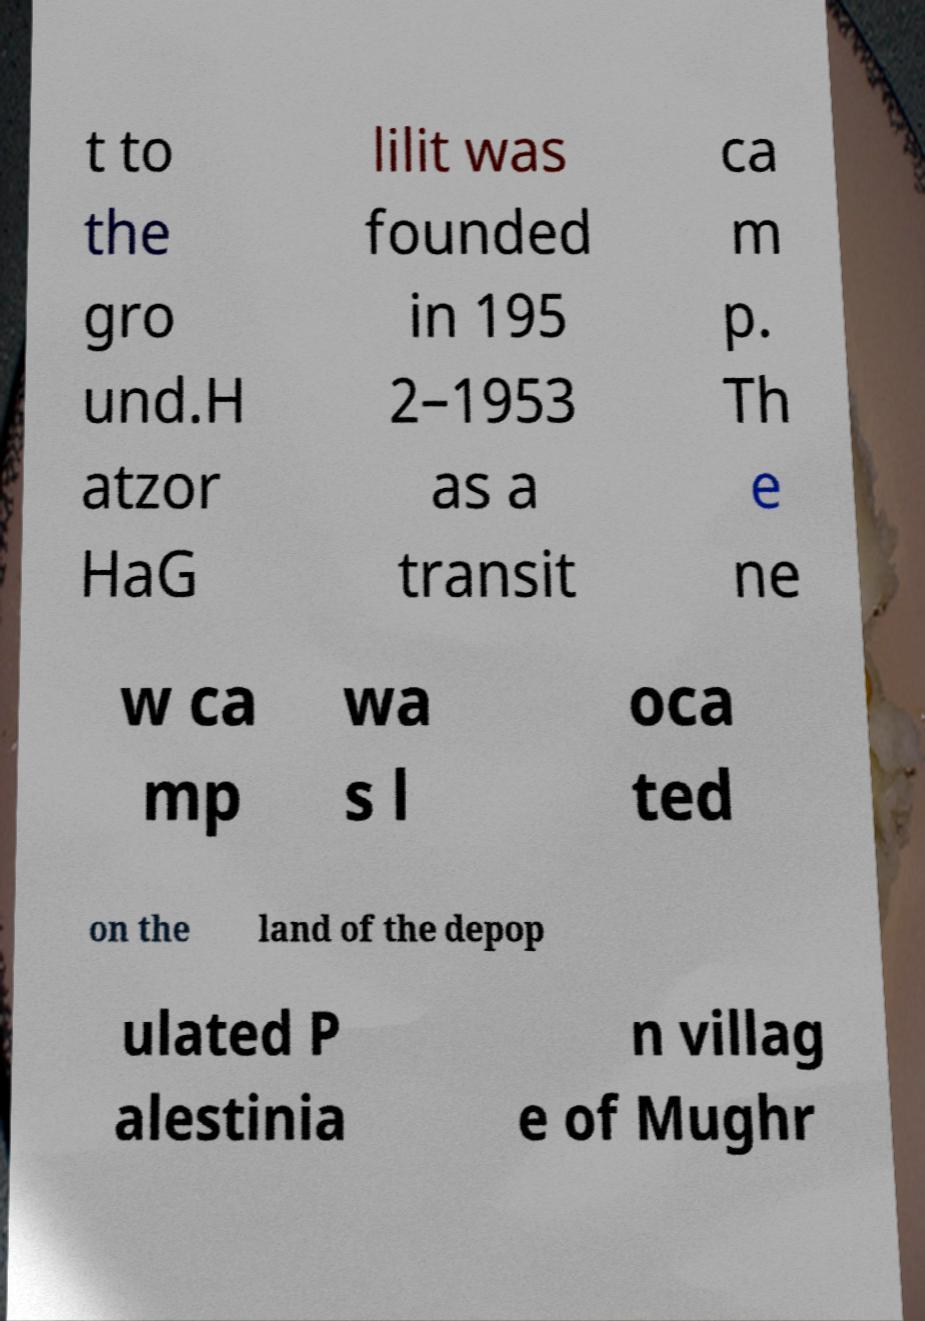Can you read and provide the text displayed in the image?This photo seems to have some interesting text. Can you extract and type it out for me? t to the gro und.H atzor HaG lilit was founded in 195 2–1953 as a transit ca m p. Th e ne w ca mp wa s l oca ted on the land of the depop ulated P alestinia n villag e of Mughr 